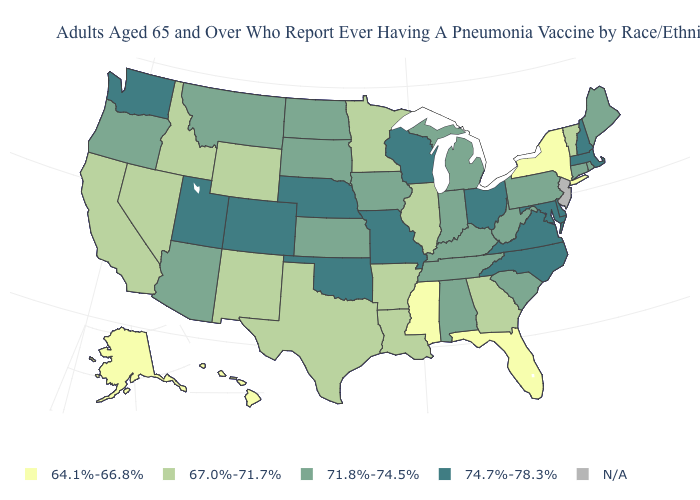What is the lowest value in the USA?
Write a very short answer. 64.1%-66.8%. What is the lowest value in the USA?
Quick response, please. 64.1%-66.8%. What is the value of Wisconsin?
Write a very short answer. 74.7%-78.3%. What is the value of Mississippi?
Quick response, please. 64.1%-66.8%. Does the map have missing data?
Keep it brief. Yes. Which states have the lowest value in the West?
Give a very brief answer. Alaska, Hawaii. Name the states that have a value in the range 71.8%-74.5%?
Concise answer only. Alabama, Arizona, Connecticut, Indiana, Iowa, Kansas, Kentucky, Maine, Michigan, Montana, North Dakota, Oregon, Pennsylvania, Rhode Island, South Carolina, South Dakota, Tennessee, West Virginia. Name the states that have a value in the range N/A?
Short answer required. New Jersey. Name the states that have a value in the range 64.1%-66.8%?
Quick response, please. Alaska, Florida, Hawaii, Mississippi, New York. What is the value of Idaho?
Keep it brief. 67.0%-71.7%. Which states have the highest value in the USA?
Be succinct. Colorado, Delaware, Maryland, Massachusetts, Missouri, Nebraska, New Hampshire, North Carolina, Ohio, Oklahoma, Utah, Virginia, Washington, Wisconsin. Name the states that have a value in the range 64.1%-66.8%?
Concise answer only. Alaska, Florida, Hawaii, Mississippi, New York. 